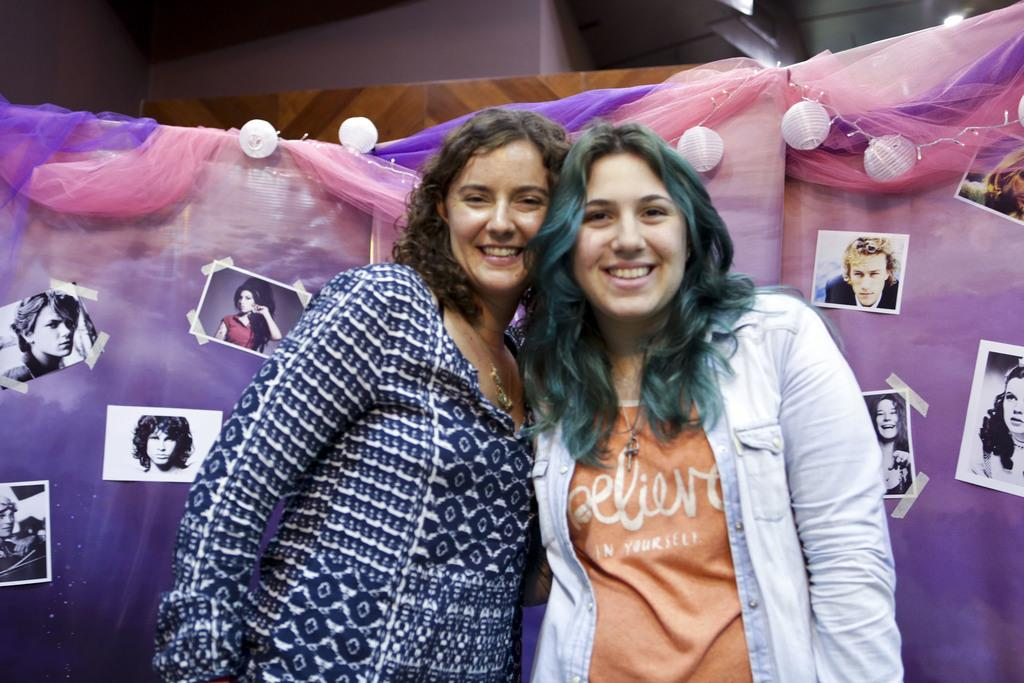How many people are present in the image? There are two people in the image. What can be seen in the background of the image? There are photo frames and decorative objects in the background of the image. What type of cheese is being used to decorate the wire in the image? There is no cheese or wire present in the image. 